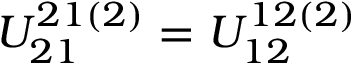<formula> <loc_0><loc_0><loc_500><loc_500>U _ { 2 1 } ^ { 2 1 ( 2 ) } = U _ { 1 2 } ^ { 1 2 ( 2 ) }</formula> 